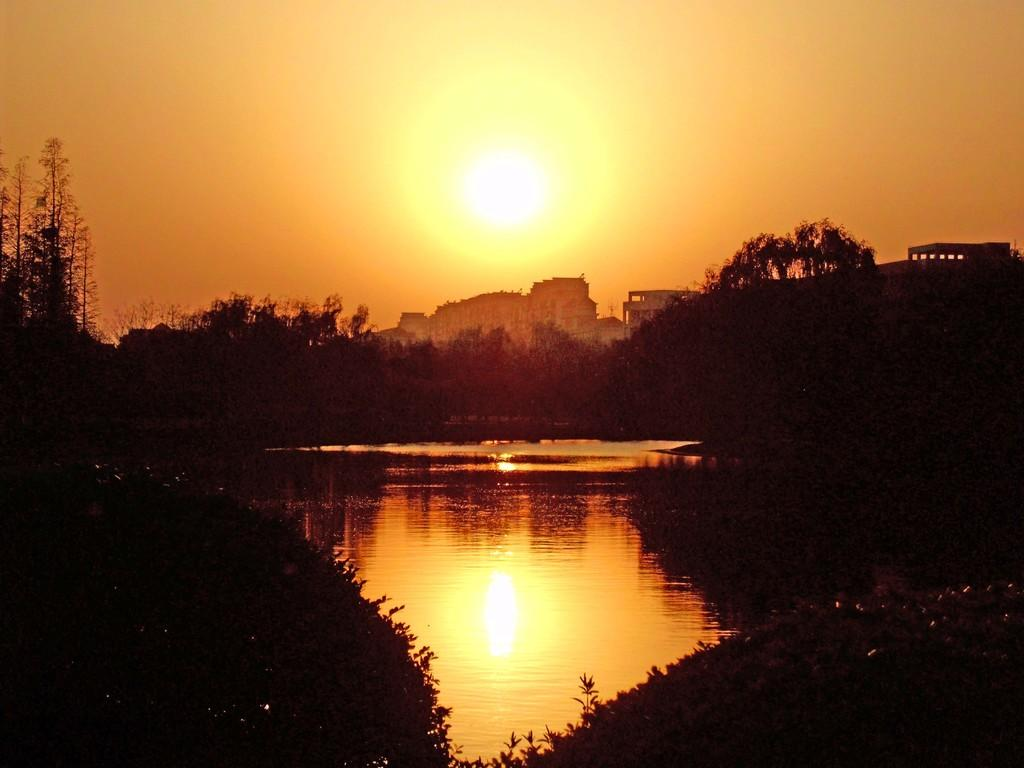What type of natural body of water is present in the image? There is a lake in the image. What type of vegetation can be seen in the image? There are trees in the image. What type of man-made structures are visible in the image? There are buildings in the image. What celestial body is visible in the sky in the image? The sun is visible in the sky in the image. What time of day is it in the image, and who is the manager of the street? The time of day cannot be determined from the image, and there is no mention of a street or a manager in the image. 